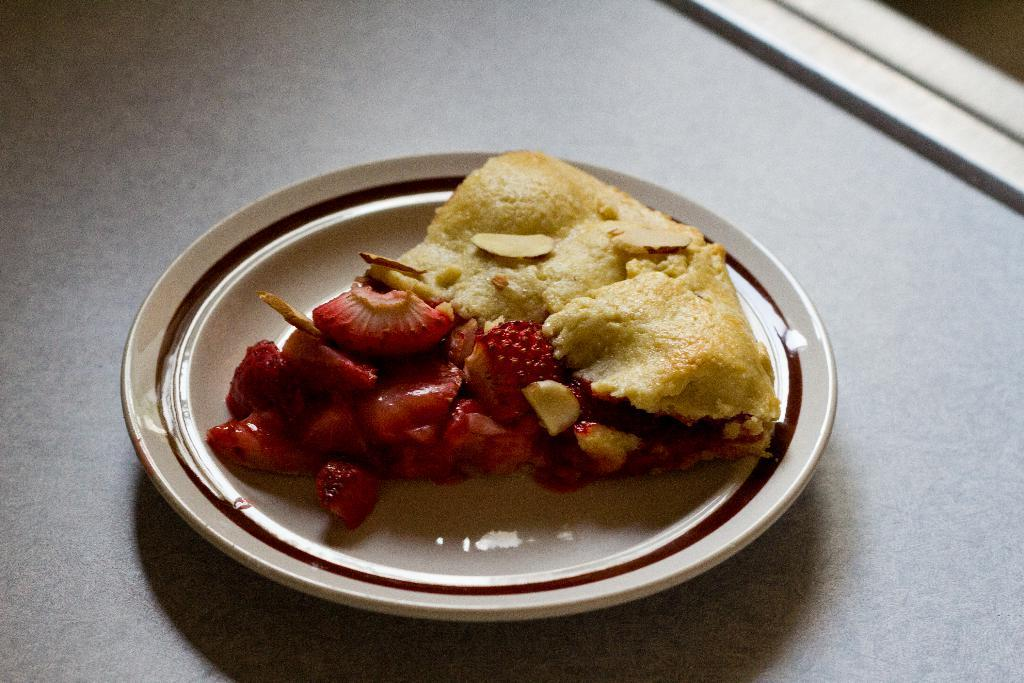What is on the plate in the image? There is food on a plate in the image. Can you describe the surface beneath the plate? There might be a table at the bottom of the image. What type of wood can be seen on the wren's nest in the image? There is no wren or nest present in the image; it only features food on a plate and possibly a table. 